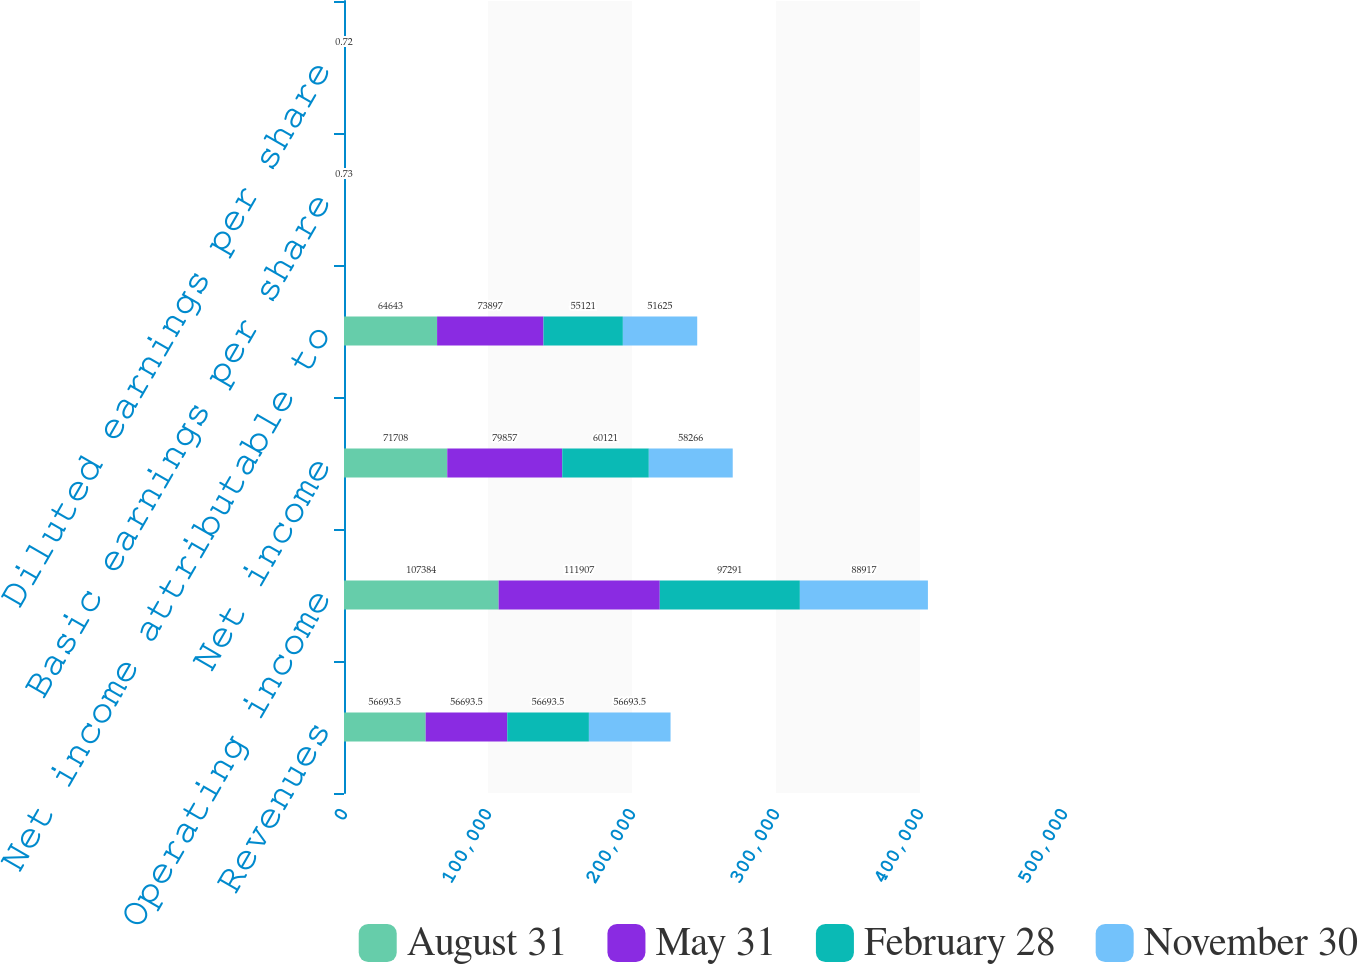<chart> <loc_0><loc_0><loc_500><loc_500><stacked_bar_chart><ecel><fcel>Revenues<fcel>Operating income<fcel>Net income<fcel>Net income attributable to<fcel>Basic earnings per share<fcel>Diluted earnings per share<nl><fcel>August 31<fcel>56693.5<fcel>107384<fcel>71708<fcel>64643<fcel>0.88<fcel>0.87<nl><fcel>May 31<fcel>56693.5<fcel>111907<fcel>79857<fcel>73897<fcel>1.02<fcel>1.02<nl><fcel>February 28<fcel>56693.5<fcel>97291<fcel>60121<fcel>55121<fcel>0.77<fcel>0.76<nl><fcel>November 30<fcel>56693.5<fcel>88917<fcel>58266<fcel>51625<fcel>0.73<fcel>0.72<nl></chart> 